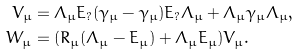Convert formula to latex. <formula><loc_0><loc_0><loc_500><loc_500>V _ { \mu } & = \Lambda _ { \mu } E _ { ? } ( \gamma _ { \bar { \mu } } - \gamma _ { \mu } ) E _ { ? } \Lambda _ { \mu } + \Lambda _ { \mu } \gamma _ { \mu } \Lambda _ { \mu } , \\ W _ { \bar { \mu } } & = ( R _ { \bar { \mu } } ( \Lambda _ { \bar { \mu } } - E _ { \bar { \mu } } ) + \Lambda _ { \mu } E _ { \bar { \mu } } ) V _ { \bar { \mu } } .</formula> 